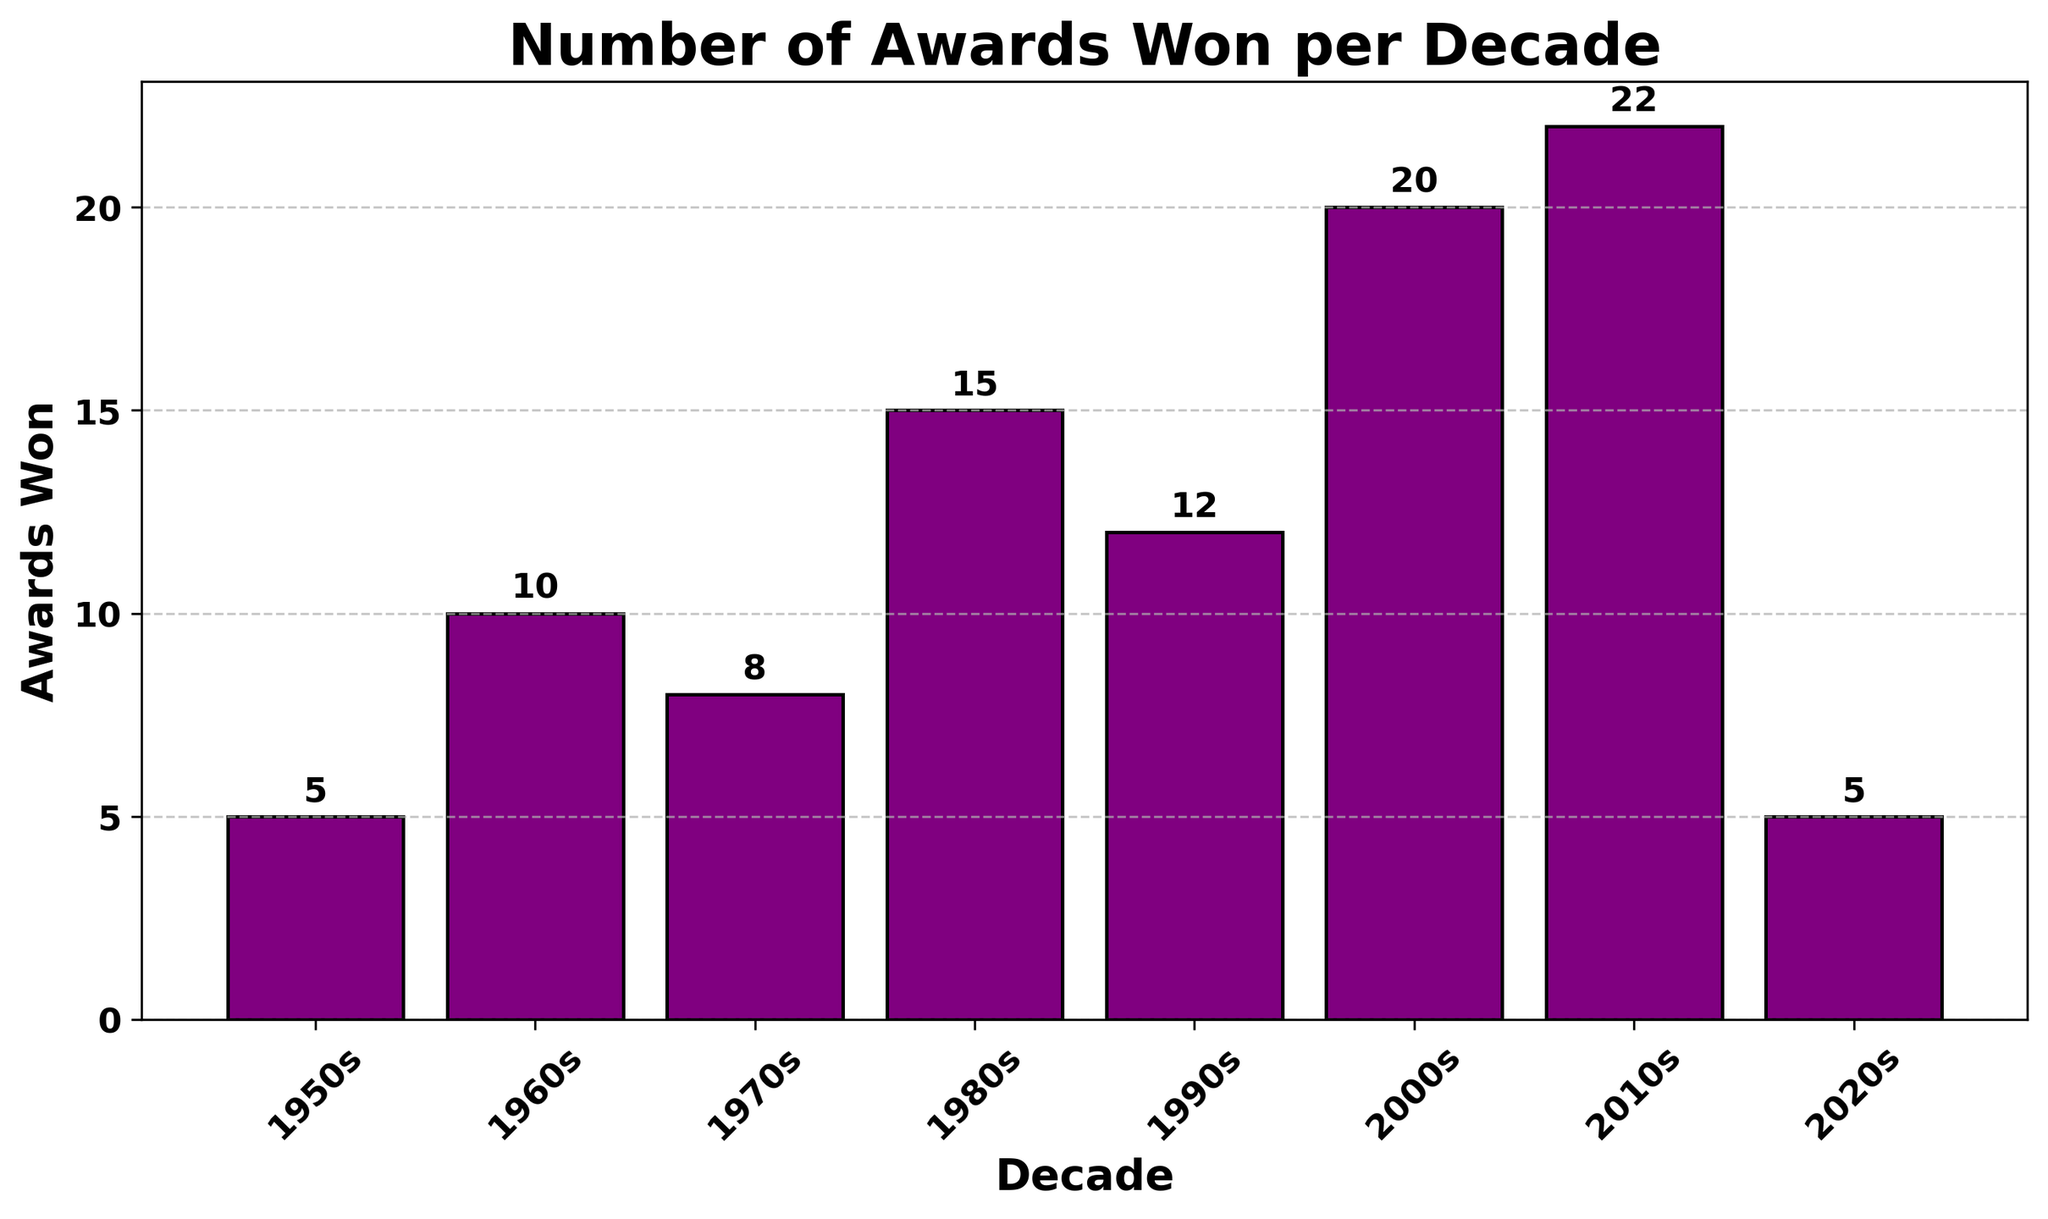How many awards were won in the decade with the highest number of awards? The decade with the highest number of awards is the 2010s as indicated by the tallest bar. The annotation reads 22.
Answer: 22 Can you calculate the total number of awards won in the 1980s and 1990s combined? From the bar chart, the 1980s had 15 awards and the 1990s had 12 awards. Summing them up: 15 + 12 = 27
Answer: 27 Which decade had fewer awards, the 1950s or the 2020s? By visually comparing the heights of the bars and their annotations, both the 1950s and the 2020s had the same number of awards, which is 5.
Answer: 1950s and 2020s both What's the difference in the number of awards between the 2000s and the 2020s? The chart shows 20 awards for the 2000s and 5 awards for the 2020s. Subtracting the two: 20 - 5 = 15
Answer: 15 Which decade showed the greatest increase in the number of awards compared to the previous decade? By comparing the increases: 
- 1950s to 1960s: 5 to 10 (+5)
- 1960s to 1970s: 10 to 8 (-2)
- 1970s to 1980s: 8 to 15 (+7)
- 1980s to 1990s: 15 to 12 (-3)
- 1990s to 2000s: 12 to 20 (+8)
- 2000s to 2010s: 20 to 22 (+2)
The greatest increase is from the 1990s to 2000s with an increase of 8 awards.
Answer: 1990s to 2000s What's the average number of awards won per decade from the 1950s to 2020s? Adding all the awards: 5 + 10 + 8 + 15 + 12 + 20 + 22 + 5 = 97. There are 8 decades. So, the average = 97 / 8 = 12.125
Answer: 12.125 What is the smallest number of awards won in any decade? By looking at the heights of the bars and their annotations, the smallest number of awards won is 5, in both the 1950s and the 2020s.
Answer: 5 